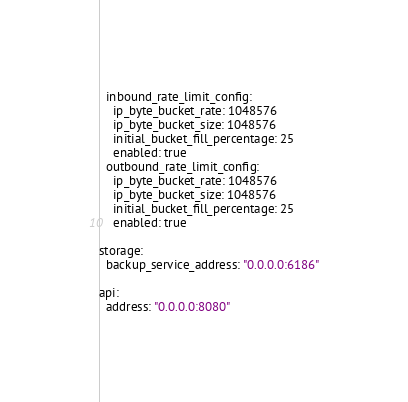<code> <loc_0><loc_0><loc_500><loc_500><_YAML_>  inbound_rate_limit_config:
    ip_byte_bucket_rate: 1048576
    ip_byte_bucket_size: 1048576
    initial_bucket_fill_percentage: 25
    enabled: true
  outbound_rate_limit_config:
    ip_byte_bucket_rate: 1048576
    ip_byte_bucket_size: 1048576
    initial_bucket_fill_percentage: 25
    enabled: true

storage:
  backup_service_address: "0.0.0.0:6186"

api:
  address: "0.0.0.0:8080"
</code> 